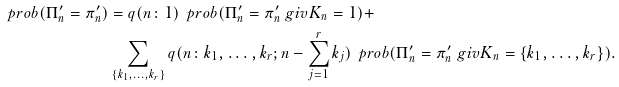Convert formula to latex. <formula><loc_0><loc_0><loc_500><loc_500>\ p r o b ( \Pi _ { n } ^ { \prime } = \pi _ { n } ^ { \prime } ) & = q ( n \colon 1 ) \, \ p r o b ( \Pi _ { n } ^ { \prime } = \pi _ { n } ^ { \prime } \ g i v K _ { n } = 1 ) + \\ & \sum _ { \{ k _ { 1 } , \dots , k _ { r } \} } q ( n \colon k _ { 1 } , \dots , k _ { r } ; n - \sum _ { j = 1 } ^ { r } k _ { j } ) \, \ p r o b ( \Pi _ { n } ^ { \prime } = \pi _ { n } ^ { \prime } \ g i v K _ { n } = \{ k _ { 1 } , \dots , k _ { r } \} ) .</formula> 